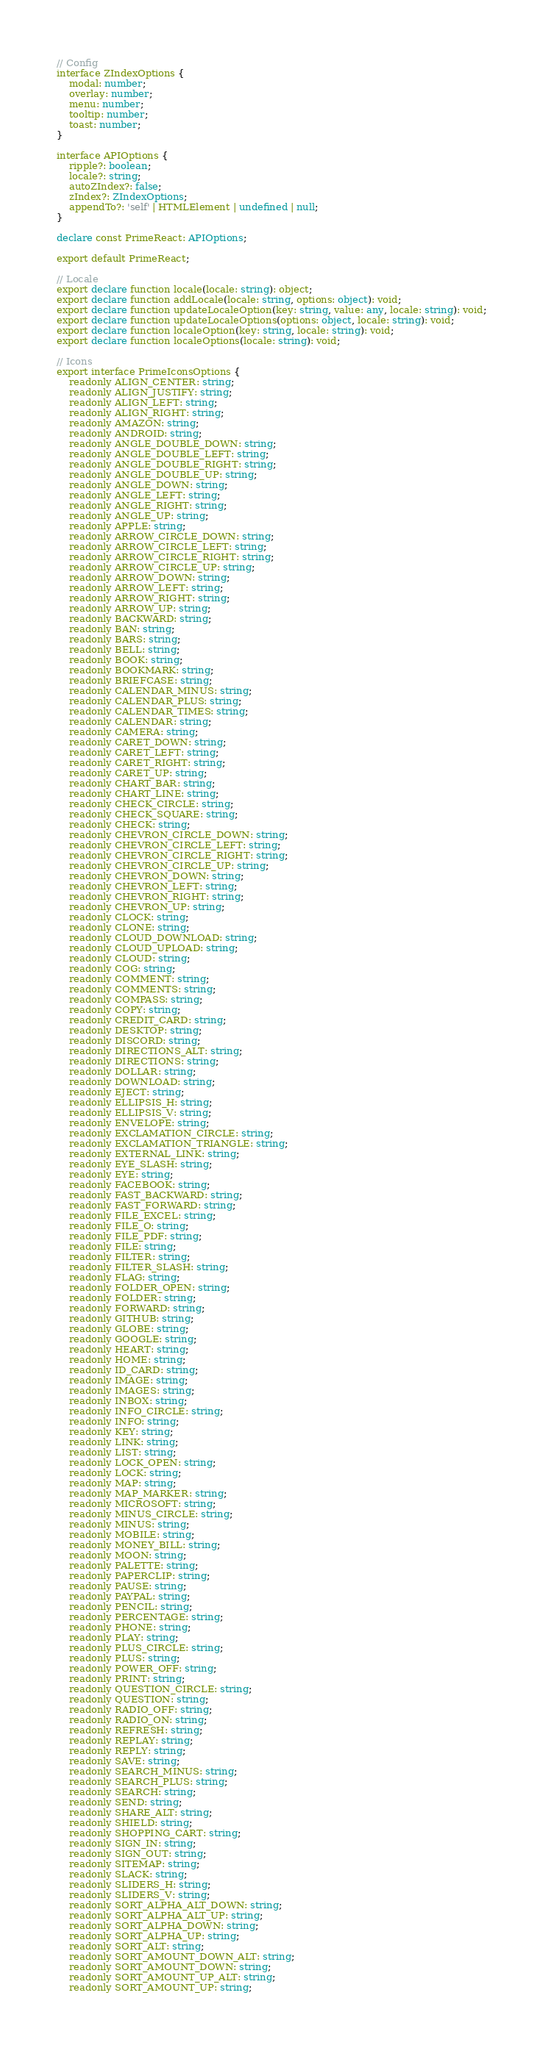Convert code to text. <code><loc_0><loc_0><loc_500><loc_500><_TypeScript_>// Config
interface ZIndexOptions {
    modal: number;
    overlay: number;
    menu: number;
    tooltip: number;
    toast: number;
}

interface APIOptions {
    ripple?: boolean;
    locale?: string;
    autoZIndex?: false;
    zIndex?: ZIndexOptions;
    appendTo?: 'self' | HTMLElement | undefined | null;
}

declare const PrimeReact: APIOptions;

export default PrimeReact;

// Locale
export declare function locale(locale: string): object;
export declare function addLocale(locale: string, options: object): void;
export declare function updateLocaleOption(key: string, value: any, locale: string): void;
export declare function updateLocaleOptions(options: object, locale: string): void;
export declare function localeOption(key: string, locale: string): void;
export declare function localeOptions(locale: string): void;

// Icons
export interface PrimeIconsOptions {
    readonly ALIGN_CENTER: string;
    readonly ALIGN_JUSTIFY: string;
    readonly ALIGN_LEFT: string;
    readonly ALIGN_RIGHT: string;
    readonly AMAZON: string;
    readonly ANDROID: string;
    readonly ANGLE_DOUBLE_DOWN: string;
    readonly ANGLE_DOUBLE_LEFT: string;
    readonly ANGLE_DOUBLE_RIGHT: string;
    readonly ANGLE_DOUBLE_UP: string;
    readonly ANGLE_DOWN: string;
    readonly ANGLE_LEFT: string;
    readonly ANGLE_RIGHT: string;
    readonly ANGLE_UP: string;
    readonly APPLE: string;
    readonly ARROW_CIRCLE_DOWN: string;
    readonly ARROW_CIRCLE_LEFT: string;
    readonly ARROW_CIRCLE_RIGHT: string;
    readonly ARROW_CIRCLE_UP: string;
    readonly ARROW_DOWN: string;
    readonly ARROW_LEFT: string;
    readonly ARROW_RIGHT: string;
    readonly ARROW_UP: string;
    readonly BACKWARD: string;
    readonly BAN: string;
    readonly BARS: string;
    readonly BELL: string;
    readonly BOOK: string;
    readonly BOOKMARK: string;
    readonly BRIEFCASE: string;
    readonly CALENDAR_MINUS: string;
    readonly CALENDAR_PLUS: string;
    readonly CALENDAR_TIMES: string;
    readonly CALENDAR: string;
    readonly CAMERA: string;
    readonly CARET_DOWN: string;
    readonly CARET_LEFT: string;
    readonly CARET_RIGHT: string;
    readonly CARET_UP: string;
    readonly CHART_BAR: string;
    readonly CHART_LINE: string;
    readonly CHECK_CIRCLE: string;
    readonly CHECK_SQUARE: string;
    readonly CHECK: string;
    readonly CHEVRON_CIRCLE_DOWN: string;
    readonly CHEVRON_CIRCLE_LEFT: string;
    readonly CHEVRON_CIRCLE_RIGHT: string;
    readonly CHEVRON_CIRCLE_UP: string;
    readonly CHEVRON_DOWN: string;
    readonly CHEVRON_LEFT: string;
    readonly CHEVRON_RIGHT: string;
    readonly CHEVRON_UP: string;
    readonly CLOCK: string;
    readonly CLONE: string;
    readonly CLOUD_DOWNLOAD: string;
    readonly CLOUD_UPLOAD: string;
    readonly CLOUD: string;
    readonly COG: string;
    readonly COMMENT: string;
    readonly COMMENTS: string;
    readonly COMPASS: string;
    readonly COPY: string;
    readonly CREDIT_CARD: string;
    readonly DESKTOP: string;
    readonly DISCORD: string;
    readonly DIRECTIONS_ALT: string;
    readonly DIRECTIONS: string;
    readonly DOLLAR: string;
    readonly DOWNLOAD: string;
    readonly EJECT: string;
    readonly ELLIPSIS_H: string;
    readonly ELLIPSIS_V: string;
    readonly ENVELOPE: string;
    readonly EXCLAMATION_CIRCLE: string;
    readonly EXCLAMATION_TRIANGLE: string;
    readonly EXTERNAL_LINK: string;
    readonly EYE_SLASH: string;
    readonly EYE: string;
    readonly FACEBOOK: string;
    readonly FAST_BACKWARD: string;
    readonly FAST_FORWARD: string;
    readonly FILE_EXCEL: string;
    readonly FILE_O: string;
    readonly FILE_PDF: string;
    readonly FILE: string;
    readonly FILTER: string;
    readonly FILTER_SLASH: string;
    readonly FLAG: string;
    readonly FOLDER_OPEN: string;
    readonly FOLDER: string;
    readonly FORWARD: string;
    readonly GITHUB: string;
    readonly GLOBE: string;
    readonly GOOGLE: string;
    readonly HEART: string;
    readonly HOME: string;
    readonly ID_CARD: string;
    readonly IMAGE: string;
    readonly IMAGES: string;
    readonly INBOX: string;
    readonly INFO_CIRCLE: string;
    readonly INFO: string;
    readonly KEY: string;
    readonly LINK: string;
    readonly LIST: string;
    readonly LOCK_OPEN: string;
    readonly LOCK: string;
    readonly MAP: string;
    readonly MAP_MARKER: string;
    readonly MICROSOFT: string;
    readonly MINUS_CIRCLE: string;
    readonly MINUS: string;
    readonly MOBILE: string;
    readonly MONEY_BILL: string;
    readonly MOON: string;
    readonly PALETTE: string;
    readonly PAPERCLIP: string;
    readonly PAUSE: string;
    readonly PAYPAL: string;
    readonly PENCIL: string;
    readonly PERCENTAGE: string;
    readonly PHONE: string;
    readonly PLAY: string;
    readonly PLUS_CIRCLE: string;
    readonly PLUS: string;
    readonly POWER_OFF: string;
    readonly PRINT: string;
    readonly QUESTION_CIRCLE: string;
    readonly QUESTION: string;
    readonly RADIO_OFF: string;
    readonly RADIO_ON: string;
    readonly REFRESH: string;
    readonly REPLAY: string;
    readonly REPLY: string;
    readonly SAVE: string;
    readonly SEARCH_MINUS: string;
    readonly SEARCH_PLUS: string;
    readonly SEARCH: string;
    readonly SEND: string;
    readonly SHARE_ALT: string;
    readonly SHIELD: string;
    readonly SHOPPING_CART: string;
    readonly SIGN_IN: string;
    readonly SIGN_OUT: string;
    readonly SITEMAP: string;
    readonly SLACK: string;
    readonly SLIDERS_H: string;
    readonly SLIDERS_V: string;
    readonly SORT_ALPHA_ALT_DOWN: string;
    readonly SORT_ALPHA_ALT_UP: string;
    readonly SORT_ALPHA_DOWN: string;
    readonly SORT_ALPHA_UP: string;
    readonly SORT_ALT: string;
    readonly SORT_AMOUNT_DOWN_ALT: string;
    readonly SORT_AMOUNT_DOWN: string;
    readonly SORT_AMOUNT_UP_ALT: string;
    readonly SORT_AMOUNT_UP: string;</code> 